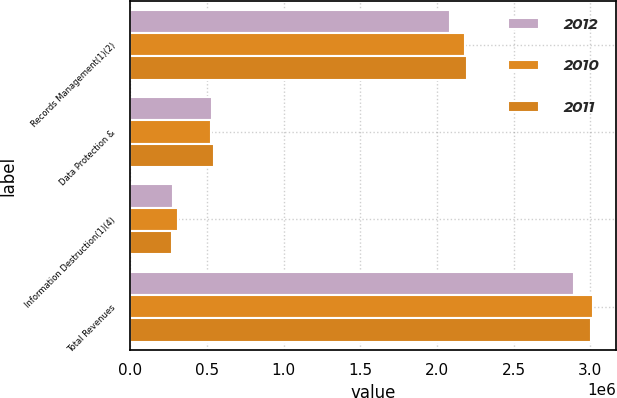Convert chart to OTSL. <chart><loc_0><loc_0><loc_500><loc_500><stacked_bar_chart><ecel><fcel>Records Management(1)(2)<fcel>Data Protection &<fcel>Information Destruction(1)(4)<fcel>Total Revenues<nl><fcel>2012<fcel>2.08149e+06<fcel>531580<fcel>279277<fcel>2.89235e+06<nl><fcel>2010<fcel>2.18315e+06<fcel>522632<fcel>308917<fcel>3.0147e+06<nl><fcel>2011<fcel>2.1936e+06<fcel>543426<fcel>268227<fcel>3.00526e+06<nl></chart> 